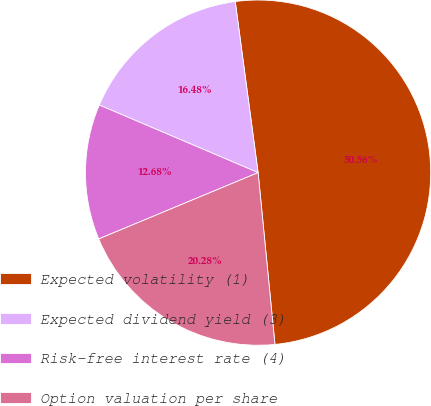<chart> <loc_0><loc_0><loc_500><loc_500><pie_chart><fcel>Expected volatility (1)<fcel>Expected dividend yield (3)<fcel>Risk-free interest rate (4)<fcel>Option valuation per share<nl><fcel>50.56%<fcel>16.48%<fcel>12.68%<fcel>20.28%<nl></chart> 